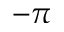Convert formula to latex. <formula><loc_0><loc_0><loc_500><loc_500>- \pi</formula> 